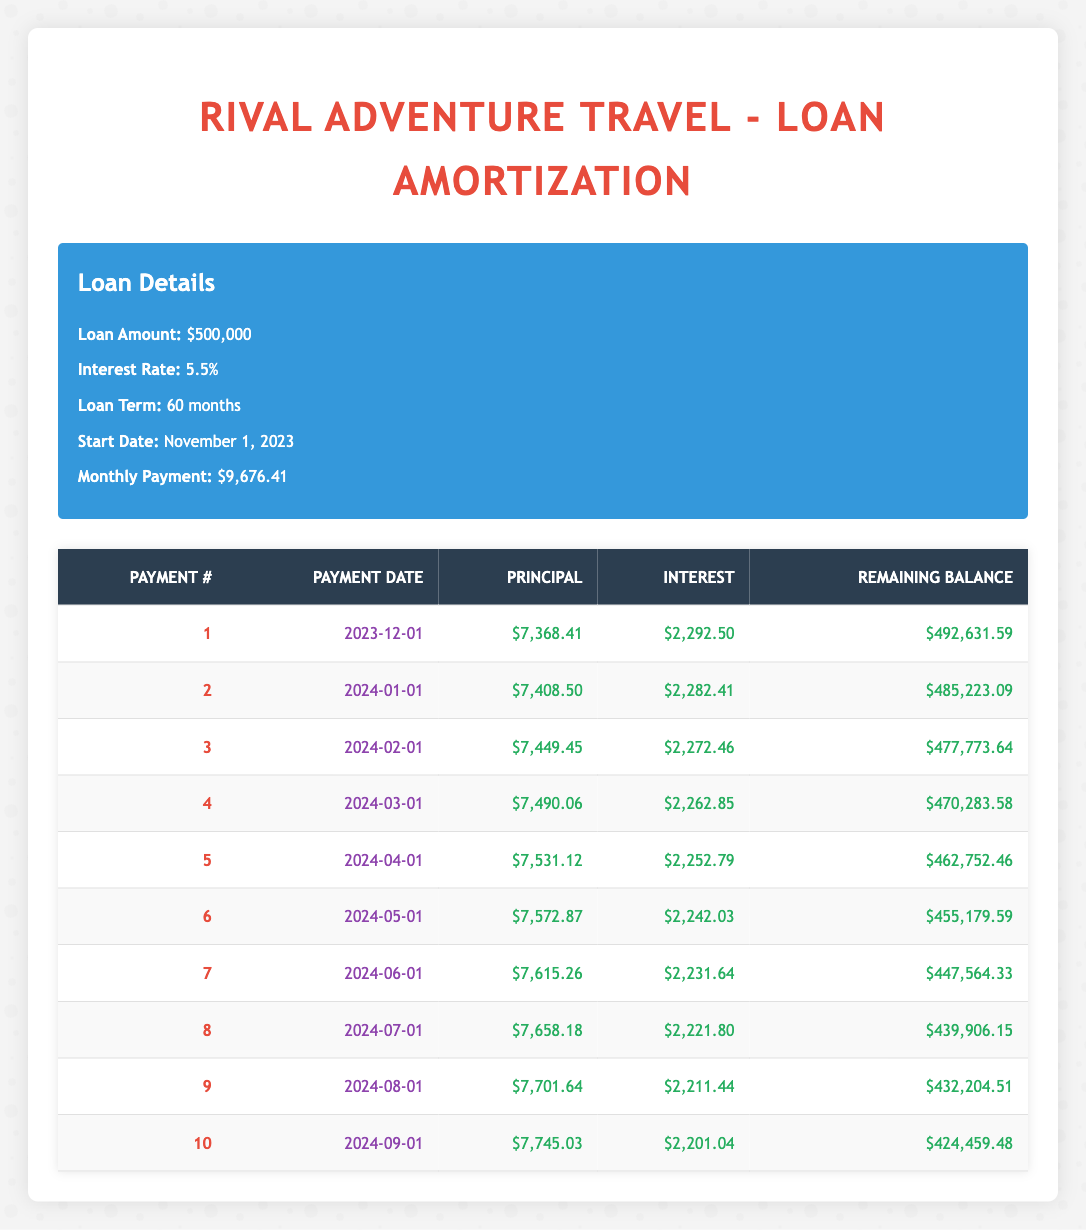What is the monthly payment amount for the loan? The loan details section states the monthly payment is $9,676.41.
Answer: 9,676.41 What is the principal payment for the first installment? By looking at the first row of the amortization schedule, the principal payment is $7,368.41.
Answer: 7,368.41 What is the total interest paid in the first three installments? To find the total interest for the first three installments, sum the interest payments: $2,292.50 + $2,282.41 + $2,272.46 = $6,847.37.
Answer: 6,847.37 Is the remaining balance after the second payment less than $485,000? The remaining balance after the second payment is $485,223.09, which is more than $485,000, so the statement is false.
Answer: No What is the average principal payment made in the first five installments? First, sum the principal payments of the first five installments: $7,368.41 + $7,408.50 + $7,449.45 + $7,490.06 + $7,531.12 = $37,247.54. Then divide by 5, so the average is $37,247.54 / 5 = $7,449.51.
Answer: 7,449.51 What month does the sixth payment occur? The sixth payment is on May 1, 2024, as shown in the sixth row of the table.
Answer: May 1, 2024 What is the difference between the principal payments of the first and last installments shown in the table? The first installment has a principal payment of $7,368.41 and the tenth installment has a principal payment of $7,745.03, so the difference is $7,745.03 - $7,368.41 = $376.62.
Answer: 376.62 Did the interest payment decrease with each installment observed up to the tenth payment? By examining the interest payments for each installment, the values decrease consistently from $2,292.50 down to $2,201.04, confirming the statement is true.
Answer: Yes What is the remaining balance after the seventh payment? According to the amortization schedule, after the seventh payment, the remaining balance is $447,564.33, as seen in the seventh row.
Answer: 447,564.33 